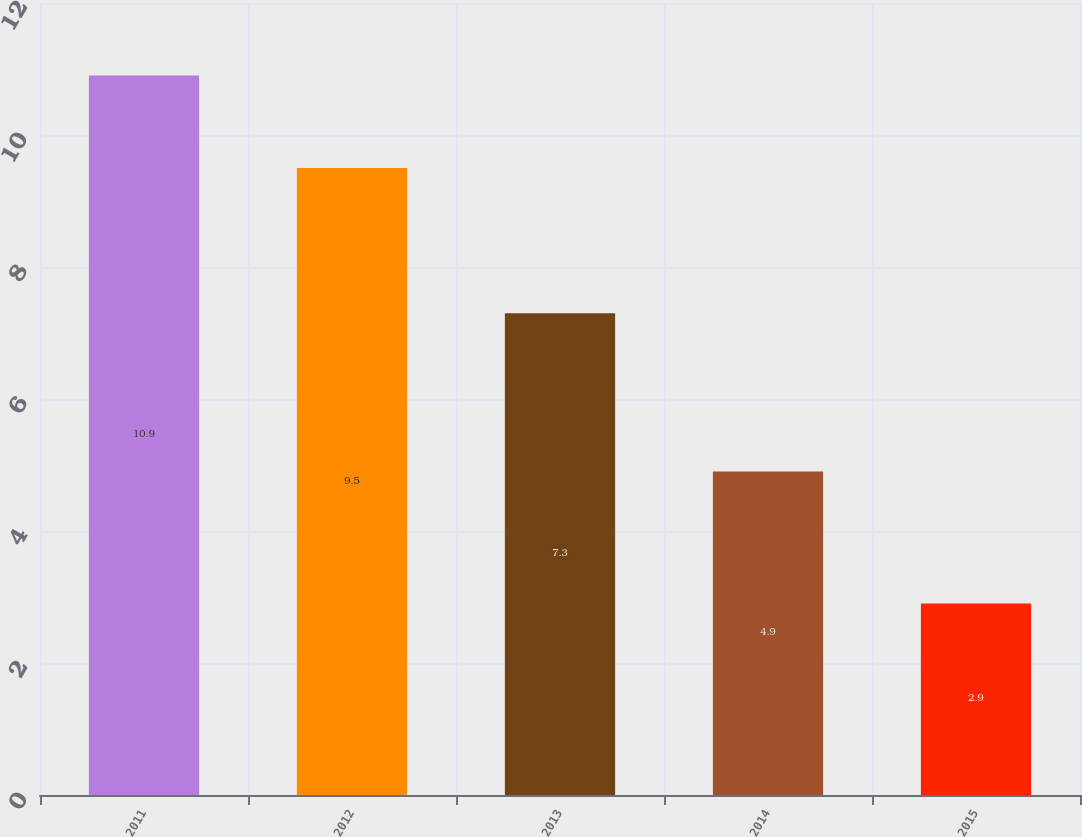Convert chart. <chart><loc_0><loc_0><loc_500><loc_500><bar_chart><fcel>2011<fcel>2012<fcel>2013<fcel>2014<fcel>2015<nl><fcel>10.9<fcel>9.5<fcel>7.3<fcel>4.9<fcel>2.9<nl></chart> 